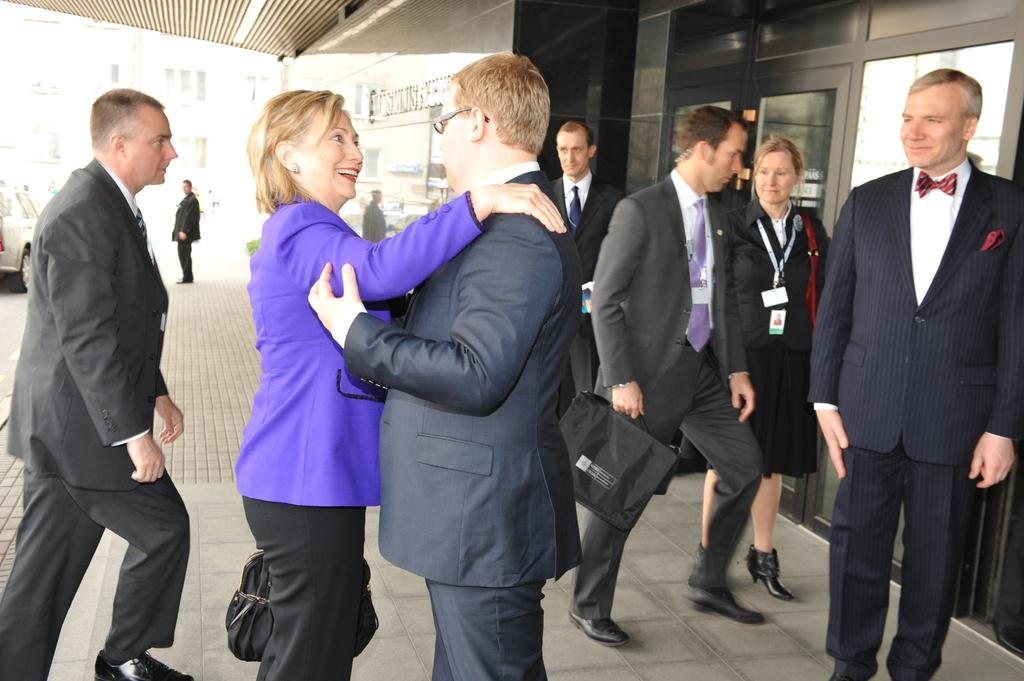What is the main subject of the image? The main subject of the image is a group of people on the ground. What are some people in the group doing? Some people in the group are holding bags. What can be seen in the background of the image? There are buildings, a vehicle, and other objects present in the background. How much money is being exchanged between the people in the image? There is no indication of money being exchanged in the image. Can you see a goose in the image? There is no goose present in the image. 